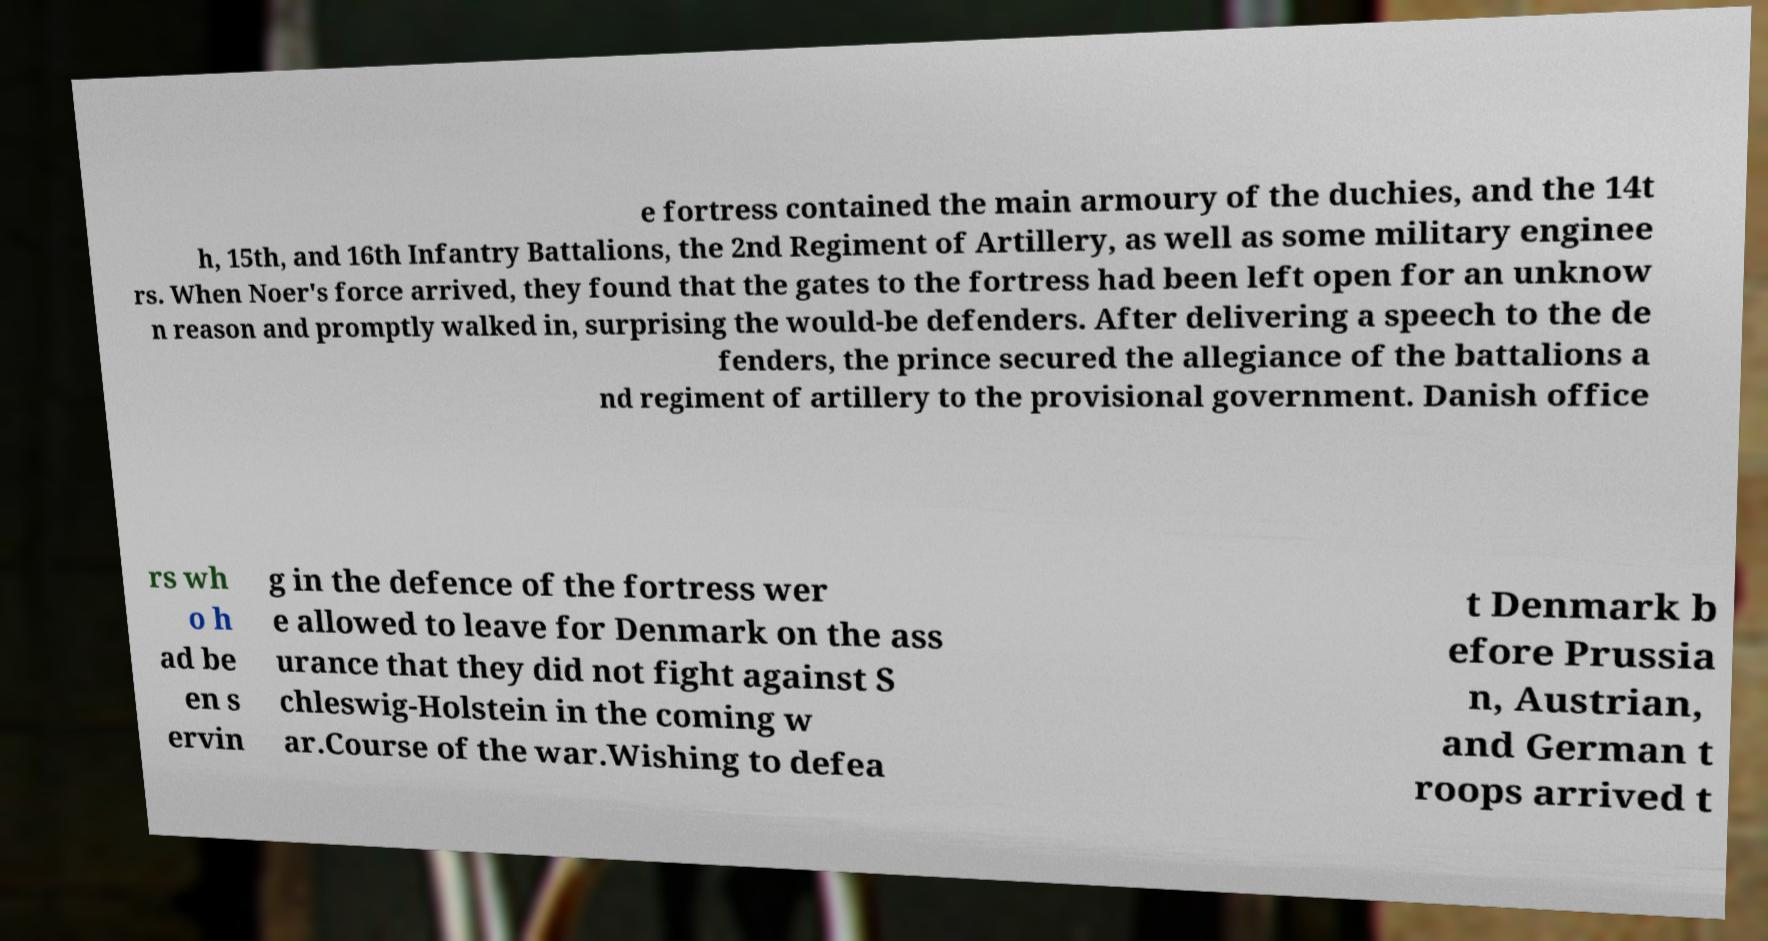Please identify and transcribe the text found in this image. e fortress contained the main armoury of the duchies, and the 14t h, 15th, and 16th Infantry Battalions, the 2nd Regiment of Artillery, as well as some military enginee rs. When Noer's force arrived, they found that the gates to the fortress had been left open for an unknow n reason and promptly walked in, surprising the would-be defenders. After delivering a speech to the de fenders, the prince secured the allegiance of the battalions a nd regiment of artillery to the provisional government. Danish office rs wh o h ad be en s ervin g in the defence of the fortress wer e allowed to leave for Denmark on the ass urance that they did not fight against S chleswig-Holstein in the coming w ar.Course of the war.Wishing to defea t Denmark b efore Prussia n, Austrian, and German t roops arrived t 